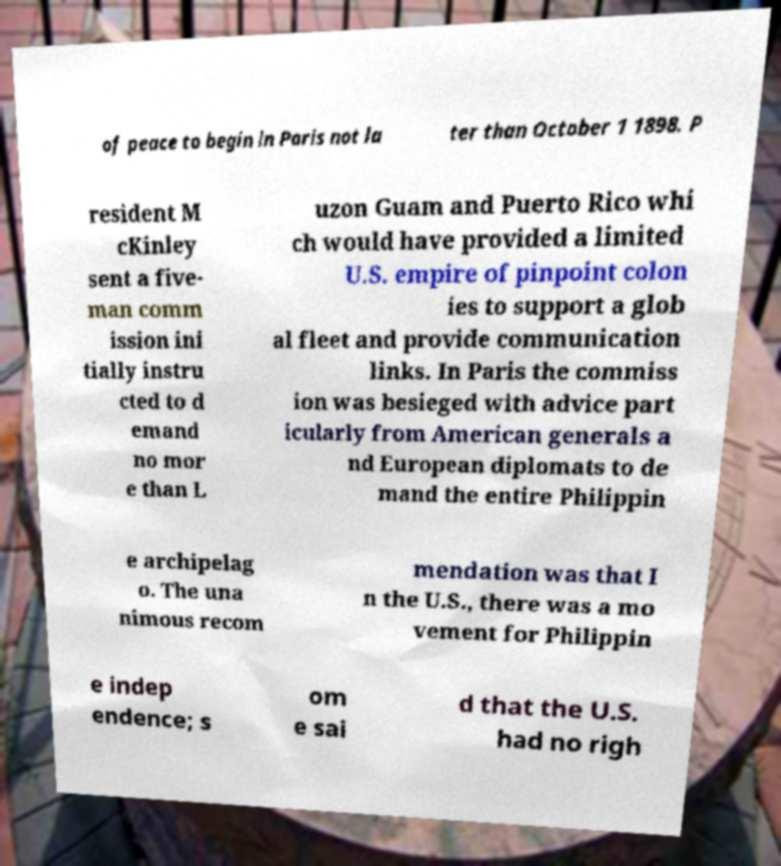For documentation purposes, I need the text within this image transcribed. Could you provide that? of peace to begin in Paris not la ter than October 1 1898. P resident M cKinley sent a five- man comm ission ini tially instru cted to d emand no mor e than L uzon Guam and Puerto Rico whi ch would have provided a limited U.S. empire of pinpoint colon ies to support a glob al fleet and provide communication links. In Paris the commiss ion was besieged with advice part icularly from American generals a nd European diplomats to de mand the entire Philippin e archipelag o. The una nimous recom mendation was that I n the U.S., there was a mo vement for Philippin e indep endence; s om e sai d that the U.S. had no righ 